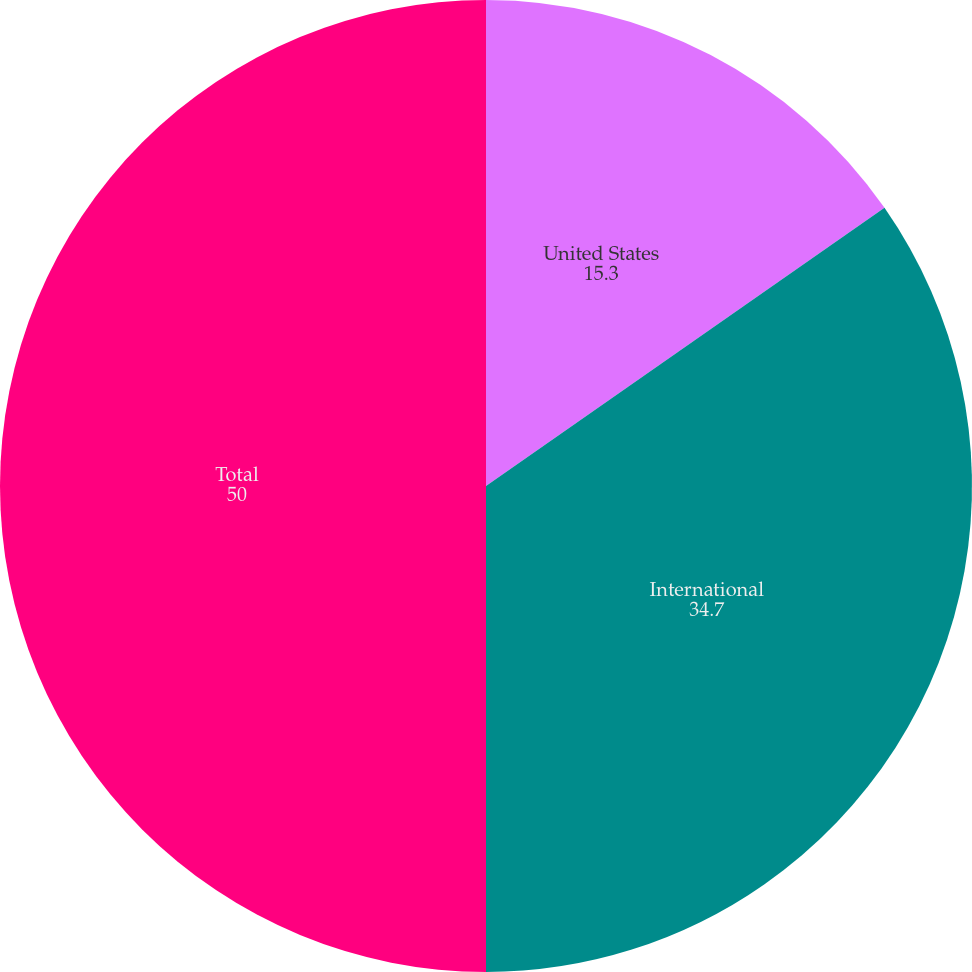Convert chart. <chart><loc_0><loc_0><loc_500><loc_500><pie_chart><fcel>United States<fcel>International<fcel>Total<nl><fcel>15.3%<fcel>34.7%<fcel>50.0%<nl></chart> 